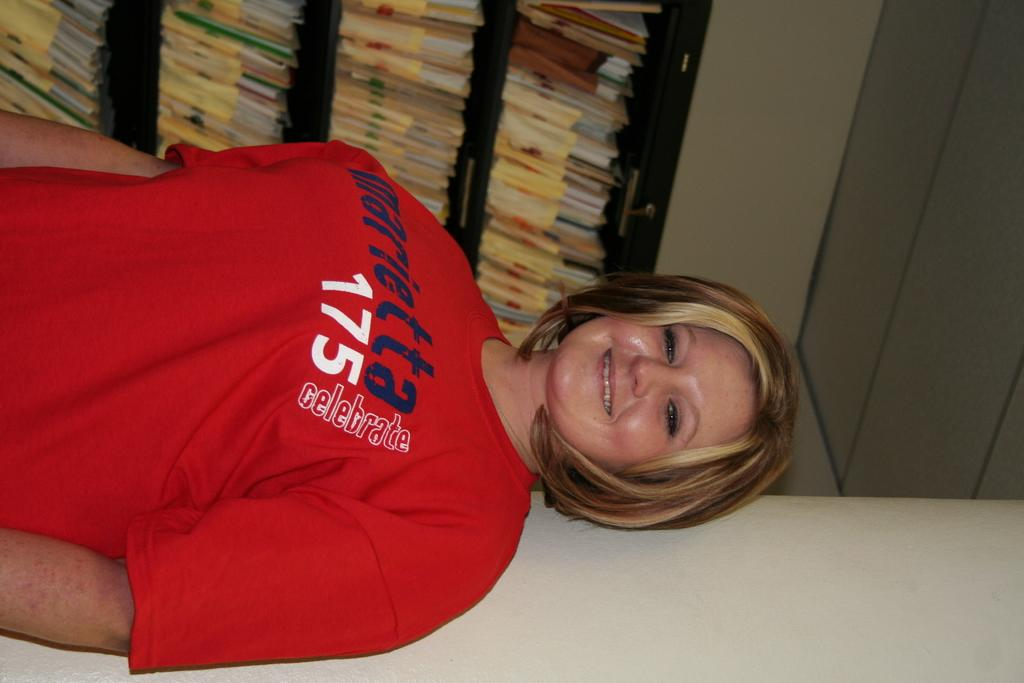<image>
Describe the image concisely. A woma wearing a red t-shirt with a Marietta 175 logo on it smiles at the camera. 